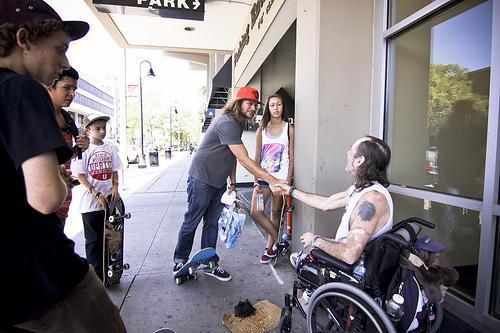How many wheelchairs are there?
Give a very brief answer. 1. How many people are there?
Give a very brief answer. 6. 